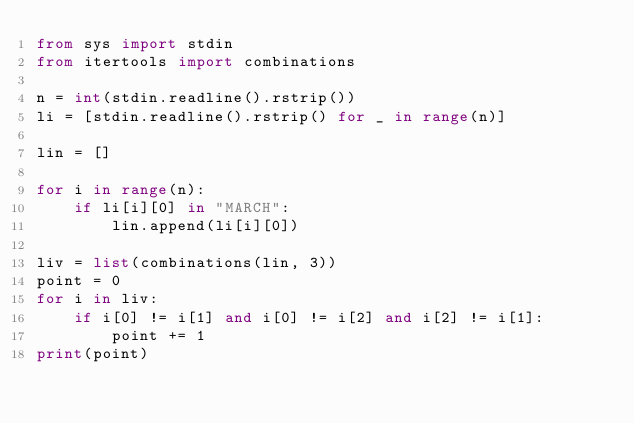Convert code to text. <code><loc_0><loc_0><loc_500><loc_500><_Python_>from sys import stdin
from itertools import combinations

n = int(stdin.readline().rstrip())
li = [stdin.readline().rstrip() for _ in range(n)]

lin = []

for i in range(n):
    if li[i][0] in "MARCH":
        lin.append(li[i][0])

liv = list(combinations(lin, 3))
point = 0
for i in liv:
    if i[0] != i[1] and i[0] != i[2] and i[2] != i[1]:
        point += 1
print(point)</code> 